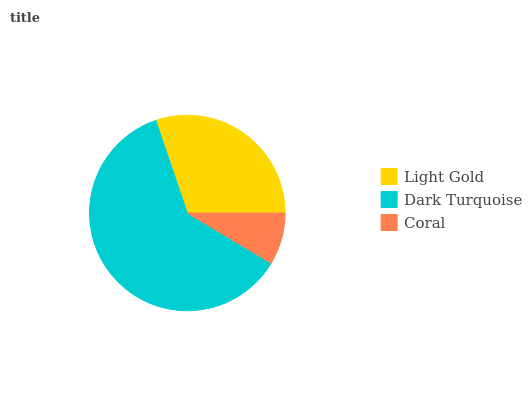Is Coral the minimum?
Answer yes or no. Yes. Is Dark Turquoise the maximum?
Answer yes or no. Yes. Is Dark Turquoise the minimum?
Answer yes or no. No. Is Coral the maximum?
Answer yes or no. No. Is Dark Turquoise greater than Coral?
Answer yes or no. Yes. Is Coral less than Dark Turquoise?
Answer yes or no. Yes. Is Coral greater than Dark Turquoise?
Answer yes or no. No. Is Dark Turquoise less than Coral?
Answer yes or no. No. Is Light Gold the high median?
Answer yes or no. Yes. Is Light Gold the low median?
Answer yes or no. Yes. Is Coral the high median?
Answer yes or no. No. Is Coral the low median?
Answer yes or no. No. 